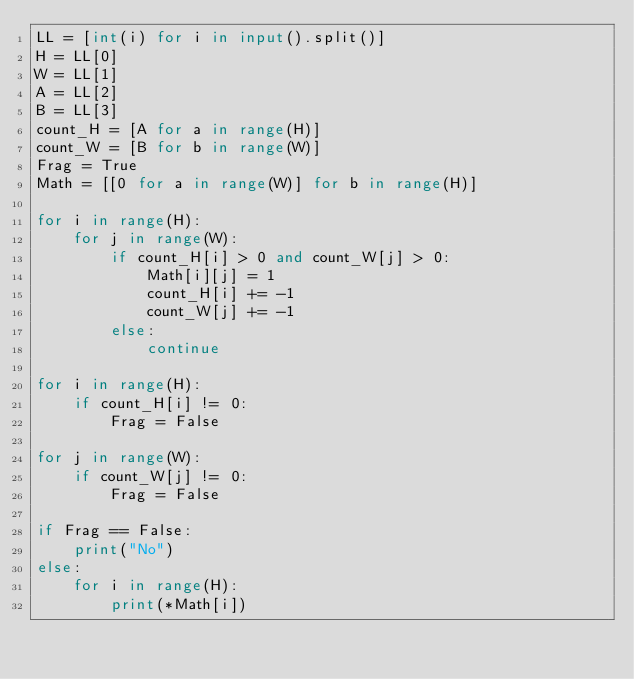Convert code to text. <code><loc_0><loc_0><loc_500><loc_500><_Python_>LL = [int(i) for i in input().split()]
H = LL[0]
W = LL[1]
A = LL[2]
B = LL[3]
count_H = [A for a in range(H)]
count_W = [B for b in range(W)]
Frag = True
Math = [[0 for a in range(W)] for b in range(H)] 

for i in range(H):
    for j in range(W):
        if count_H[i] > 0 and count_W[j] > 0:
            Math[i][j] = 1
            count_H[i] += -1
            count_W[j] += -1
        else:
            continue

for i in range(H):
    if count_H[i] != 0:
        Frag = False

for j in range(W):
    if count_W[j] != 0:
        Frag = False

if Frag == False:
    print("No")
else:
    for i in range(H):
        print(*Math[i])</code> 